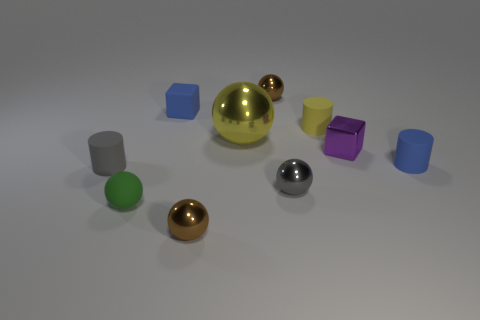There is a blue object that is the same shape as the tiny purple metal thing; what is its material?
Ensure brevity in your answer.  Rubber. Is there any other thing that has the same material as the large object?
Provide a succinct answer. Yes. What number of yellow things are small balls or small metallic blocks?
Offer a terse response. 0. There is a small gray thing to the right of the big metal ball; what is its material?
Give a very brief answer. Metal. Are there more tiny green rubber spheres than tiny yellow metallic balls?
Provide a short and direct response. Yes. Do the tiny brown metallic thing to the left of the large shiny ball and the yellow matte object have the same shape?
Provide a succinct answer. No. What number of tiny objects are both on the right side of the big yellow object and in front of the small blue cylinder?
Ensure brevity in your answer.  1. What number of green matte objects have the same shape as the large yellow thing?
Your answer should be compact. 1. What is the color of the small ball on the left side of the small brown shiny sphere that is in front of the tiny gray rubber cylinder?
Keep it short and to the point. Green. There is a tiny green rubber object; is it the same shape as the tiny gray thing that is on the left side of the small blue rubber block?
Offer a terse response. No. 